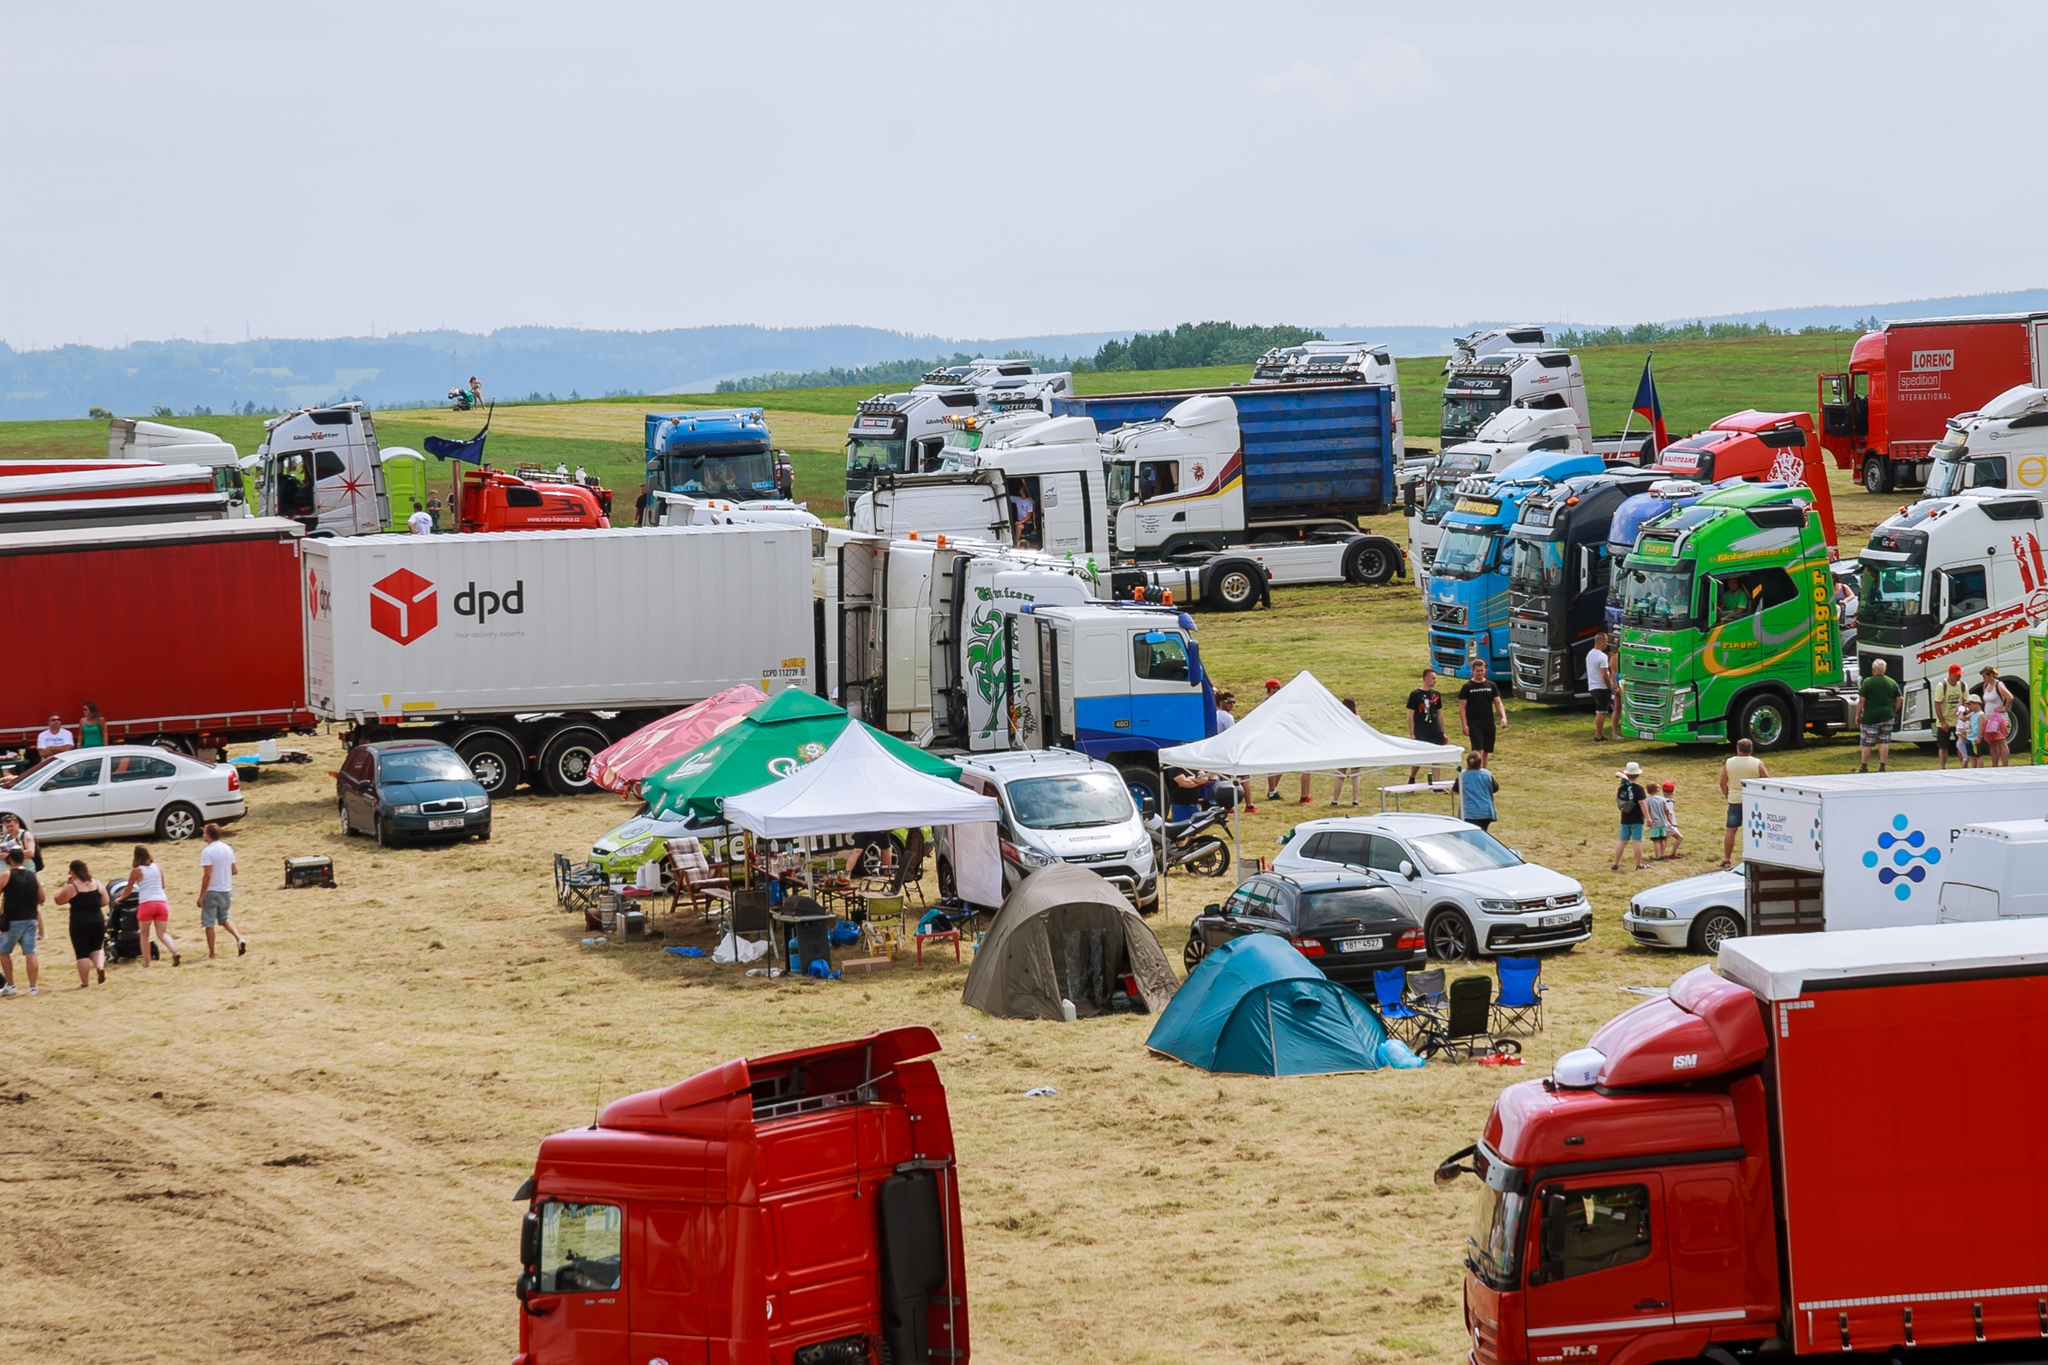Based on the setup and organization, what might be the scale and sponsorship level of this event? Observing the array of well-maintained trucks featuring prominent logos, and the structured layout of the event, it appears to be a well-organized, possibly large-scale gathering. The presence of internationally recognized brands like DPD suggests corporate sponsorship, indicating a significant level of planning and investment. This aligns with larger, perhaps national or even international, events in the transport and logistics industry. Such sponsorships hint at not only promotional opportunities for the companies involved but also a well-supported platform for showcasing industry advancements and fostering professional relationships. 